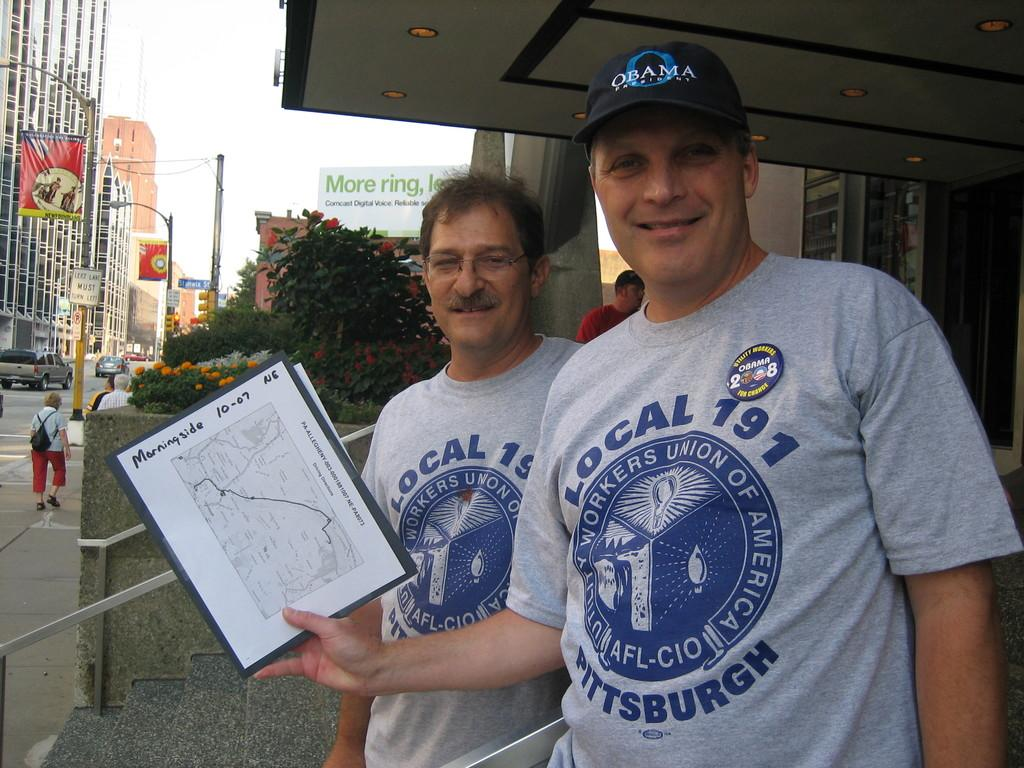Provide a one-sentence caption for the provided image. Two members of a local Pittsburgh union show a map of the Morningside neighborhood. 